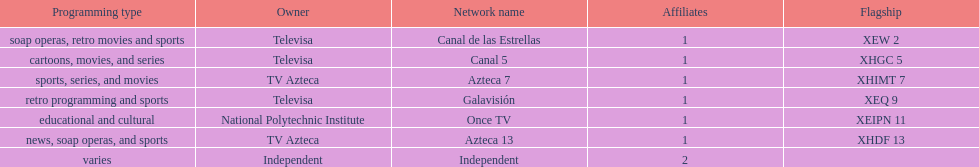Who is the owner of both azteca 7 and azteca 13? TV Azteca. 